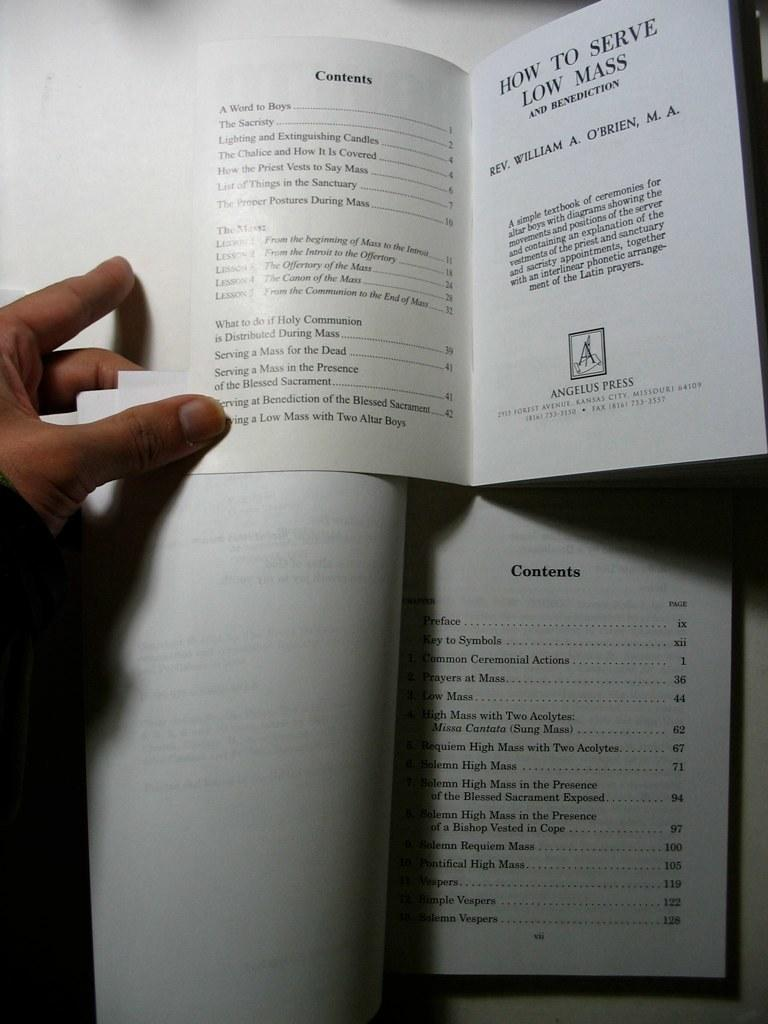<image>
Describe the image concisely. An instruction on how to do a mass is shown on top of another book on catholic mass. 